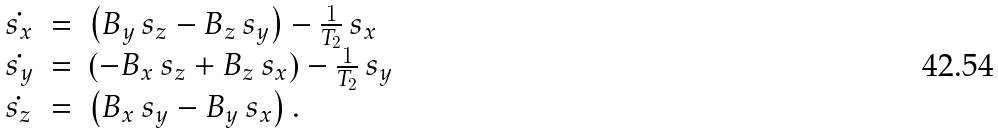<formula> <loc_0><loc_0><loc_500><loc_500>\begin{array} { l l l } \dot { s _ { x } } & = & \left ( B _ { y } \, s _ { z } - B _ { z } \, s _ { y } \right ) - \frac { 1 } { T _ { 2 } } \, s _ { x } \\ \dot { s _ { y } } & = & \left ( - B _ { x } \, s _ { z } + B _ { z } \, s _ { x } \right ) - \frac { 1 } { T _ { 2 } } \, s _ { y } \\ \dot { s _ { z } } & = & \left ( B _ { x } \, s _ { y } - B _ { y } \, s _ { x } \right ) . \end{array}</formula> 